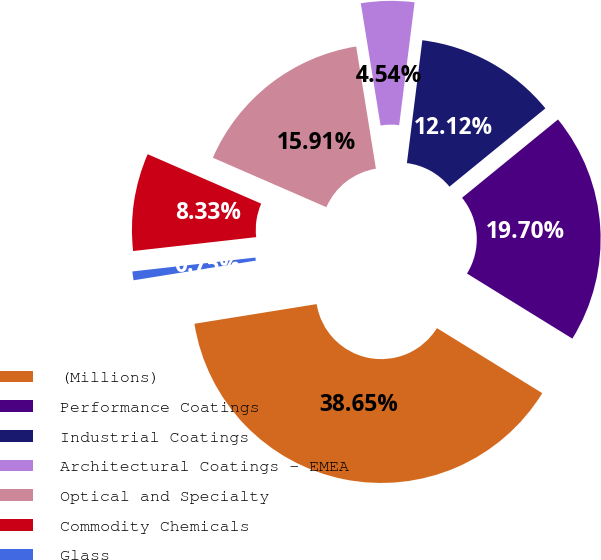Convert chart. <chart><loc_0><loc_0><loc_500><loc_500><pie_chart><fcel>(Millions)<fcel>Performance Coatings<fcel>Industrial Coatings<fcel>Architectural Coatings - EMEA<fcel>Optical and Specialty<fcel>Commodity Chemicals<fcel>Glass<nl><fcel>38.65%<fcel>19.7%<fcel>12.12%<fcel>4.54%<fcel>15.91%<fcel>8.33%<fcel>0.75%<nl></chart> 